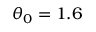<formula> <loc_0><loc_0><loc_500><loc_500>\theta _ { 0 } = 1 . 6</formula> 